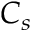Convert formula to latex. <formula><loc_0><loc_0><loc_500><loc_500>C _ { s }</formula> 